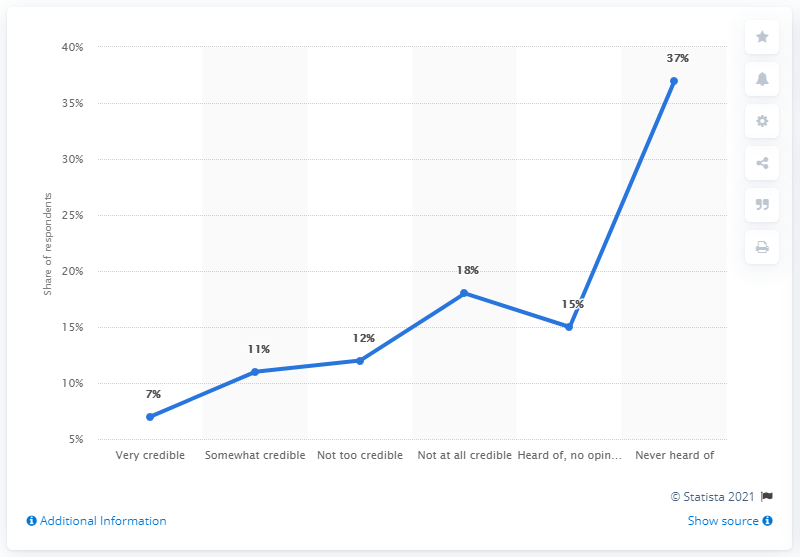Indicate a few pertinent items in this graphic. According to the respondent, 7% has a very credible share. The combined percentage of respondents who found the information not too credible and not at all credible is 30%. 